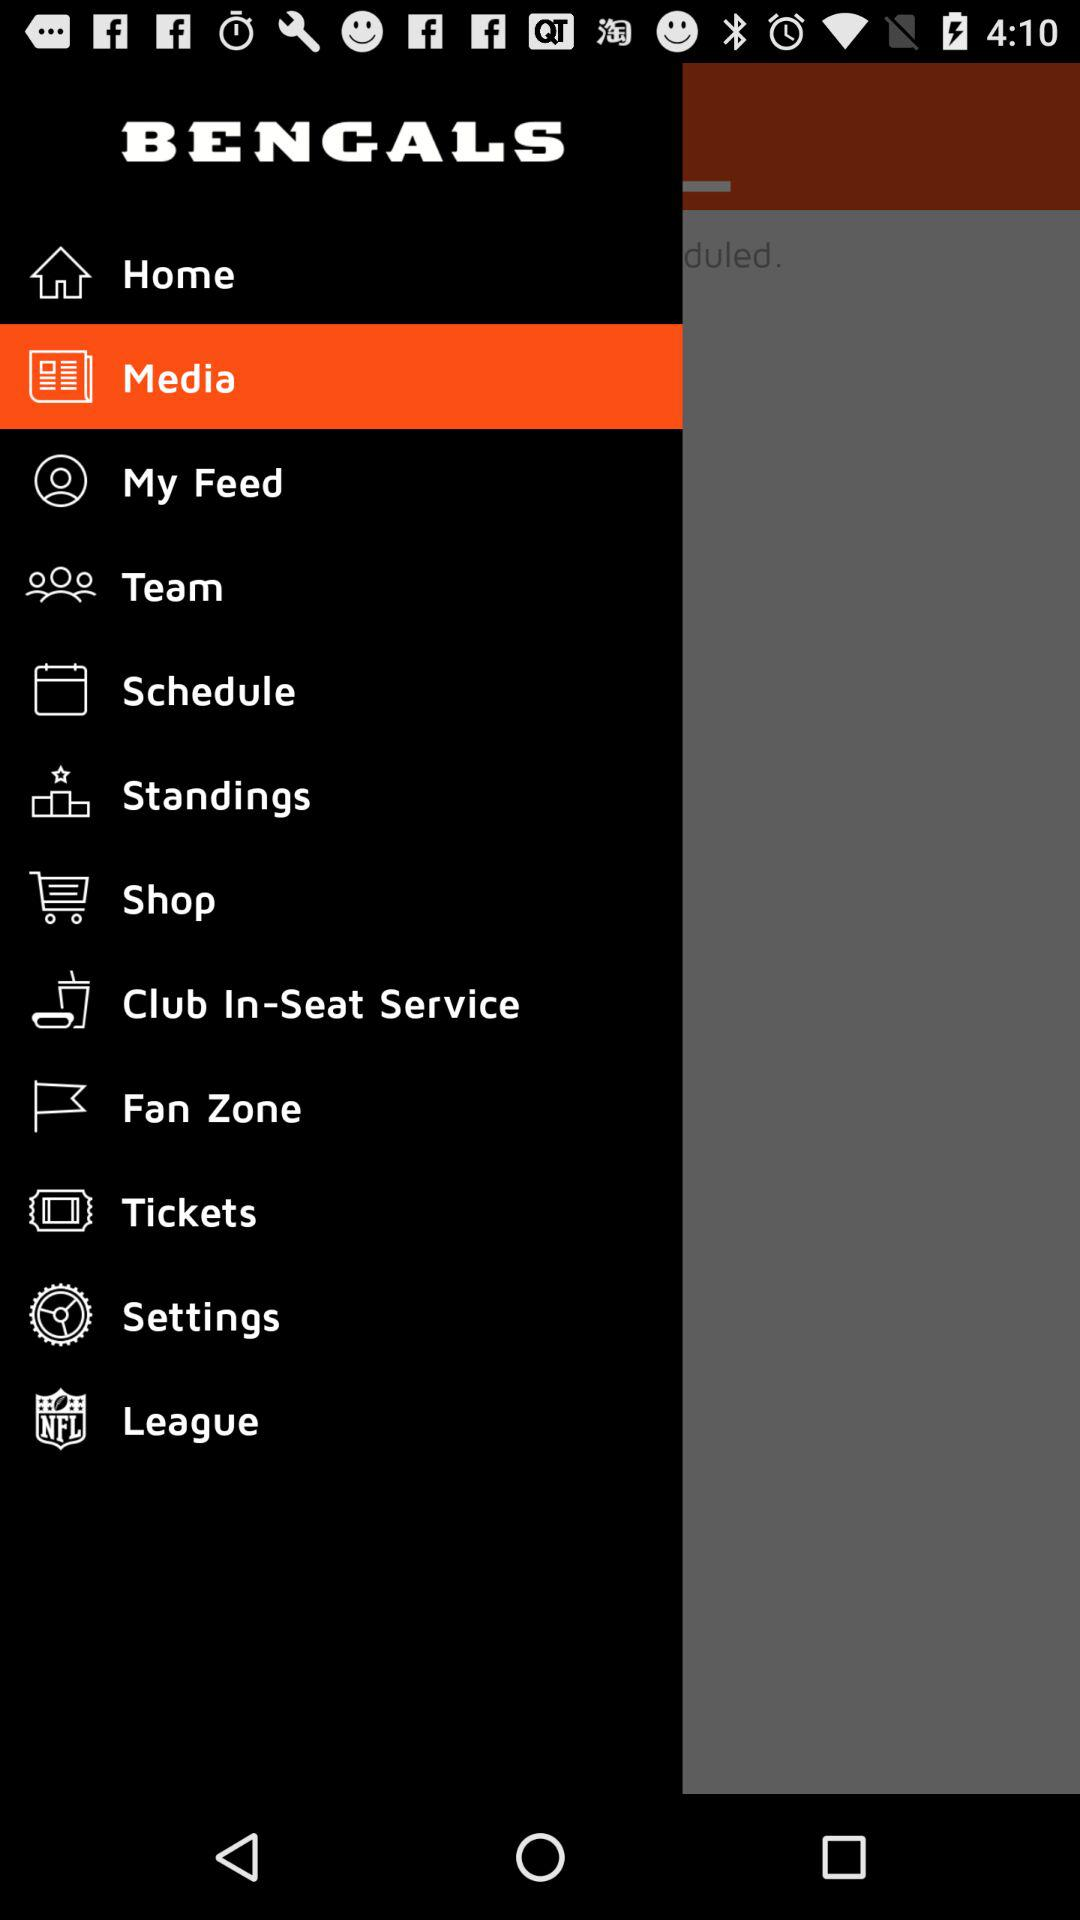What is the name of the application? The name of the application is "BENGALS". 